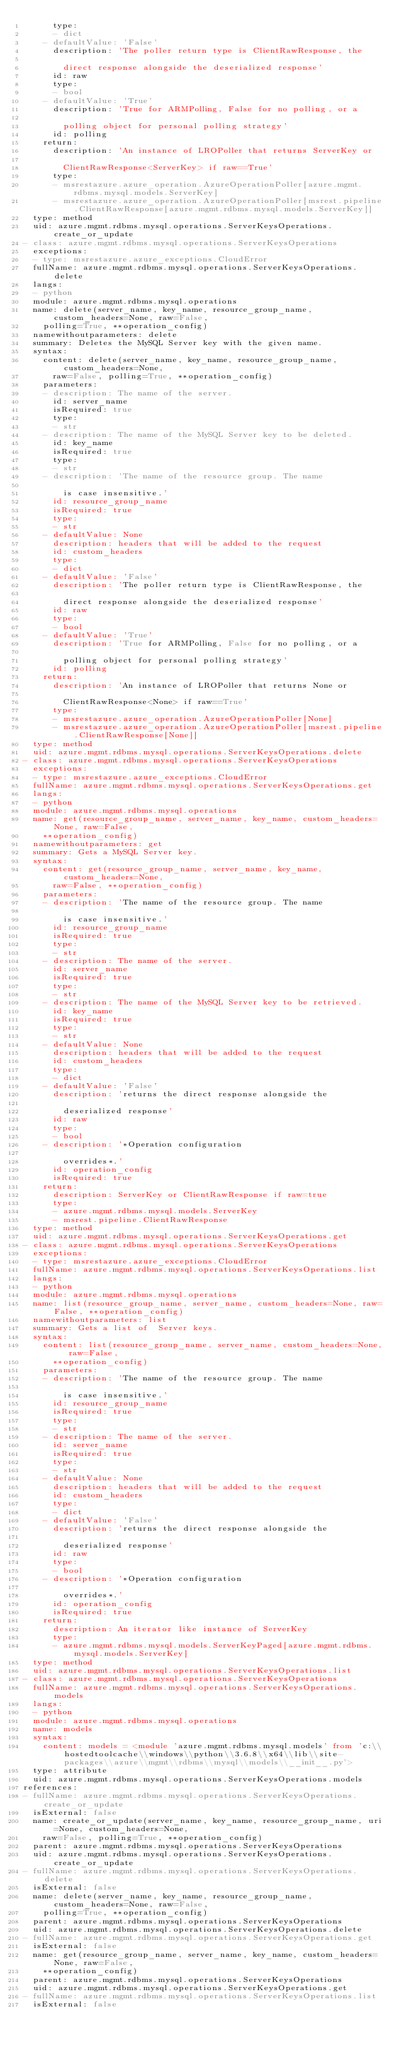<code> <loc_0><loc_0><loc_500><loc_500><_YAML_>      type:
      - dict
    - defaultValue: 'False'
      description: 'The poller return type is ClientRawResponse, the

        direct response alongside the deserialized response'
      id: raw
      type:
      - bool
    - defaultValue: 'True'
      description: 'True for ARMPolling, False for no polling, or a

        polling object for personal polling strategy'
      id: polling
    return:
      description: 'An instance of LROPoller that returns ServerKey or

        ClientRawResponse<ServerKey> if raw==True'
      type:
      - msrestazure.azure_operation.AzureOperationPoller[azure.mgmt.rdbms.mysql.models.ServerKey]
      - msrestazure.azure_operation.AzureOperationPoller[msrest.pipeline.ClientRawResponse[azure.mgmt.rdbms.mysql.models.ServerKey]]
  type: method
  uid: azure.mgmt.rdbms.mysql.operations.ServerKeysOperations.create_or_update
- class: azure.mgmt.rdbms.mysql.operations.ServerKeysOperations
  exceptions:
  - type: msrestazure.azure_exceptions.CloudError
  fullName: azure.mgmt.rdbms.mysql.operations.ServerKeysOperations.delete
  langs:
  - python
  module: azure.mgmt.rdbms.mysql.operations
  name: delete(server_name, key_name, resource_group_name, custom_headers=None, raw=False,
    polling=True, **operation_config)
  namewithoutparameters: delete
  summary: Deletes the MySQL Server key with the given name.
  syntax:
    content: delete(server_name, key_name, resource_group_name, custom_headers=None,
      raw=False, polling=True, **operation_config)
    parameters:
    - description: The name of the server.
      id: server_name
      isRequired: true
      type:
      - str
    - description: The name of the MySQL Server key to be deleted.
      id: key_name
      isRequired: true
      type:
      - str
    - description: 'The name of the resource group. The name

        is case insensitive.'
      id: resource_group_name
      isRequired: true
      type:
      - str
    - defaultValue: None
      description: headers that will be added to the request
      id: custom_headers
      type:
      - dict
    - defaultValue: 'False'
      description: 'The poller return type is ClientRawResponse, the

        direct response alongside the deserialized response'
      id: raw
      type:
      - bool
    - defaultValue: 'True'
      description: 'True for ARMPolling, False for no polling, or a

        polling object for personal polling strategy'
      id: polling
    return:
      description: 'An instance of LROPoller that returns None or

        ClientRawResponse<None> if raw==True'
      type:
      - msrestazure.azure_operation.AzureOperationPoller[None]
      - msrestazure.azure_operation.AzureOperationPoller[msrest.pipeline.ClientRawResponse[None]]
  type: method
  uid: azure.mgmt.rdbms.mysql.operations.ServerKeysOperations.delete
- class: azure.mgmt.rdbms.mysql.operations.ServerKeysOperations
  exceptions:
  - type: msrestazure.azure_exceptions.CloudError
  fullName: azure.mgmt.rdbms.mysql.operations.ServerKeysOperations.get
  langs:
  - python
  module: azure.mgmt.rdbms.mysql.operations
  name: get(resource_group_name, server_name, key_name, custom_headers=None, raw=False,
    **operation_config)
  namewithoutparameters: get
  summary: Gets a MySQL Server key.
  syntax:
    content: get(resource_group_name, server_name, key_name, custom_headers=None,
      raw=False, **operation_config)
    parameters:
    - description: 'The name of the resource group. The name

        is case insensitive.'
      id: resource_group_name
      isRequired: true
      type:
      - str
    - description: The name of the server.
      id: server_name
      isRequired: true
      type:
      - str
    - description: The name of the MySQL Server key to be retrieved.
      id: key_name
      isRequired: true
      type:
      - str
    - defaultValue: None
      description: headers that will be added to the request
      id: custom_headers
      type:
      - dict
    - defaultValue: 'False'
      description: 'returns the direct response alongside the

        deserialized response'
      id: raw
      type:
      - bool
    - description: '*Operation configuration

        overrides*.'
      id: operation_config
      isRequired: true
    return:
      description: ServerKey or ClientRawResponse if raw=true
      type:
      - azure.mgmt.rdbms.mysql.models.ServerKey
      - msrest.pipeline.ClientRawResponse
  type: method
  uid: azure.mgmt.rdbms.mysql.operations.ServerKeysOperations.get
- class: azure.mgmt.rdbms.mysql.operations.ServerKeysOperations
  exceptions:
  - type: msrestazure.azure_exceptions.CloudError
  fullName: azure.mgmt.rdbms.mysql.operations.ServerKeysOperations.list
  langs:
  - python
  module: azure.mgmt.rdbms.mysql.operations
  name: list(resource_group_name, server_name, custom_headers=None, raw=False, **operation_config)
  namewithoutparameters: list
  summary: Gets a list of  Server keys.
  syntax:
    content: list(resource_group_name, server_name, custom_headers=None, raw=False,
      **operation_config)
    parameters:
    - description: 'The name of the resource group. The name

        is case insensitive.'
      id: resource_group_name
      isRequired: true
      type:
      - str
    - description: The name of the server.
      id: server_name
      isRequired: true
      type:
      - str
    - defaultValue: None
      description: headers that will be added to the request
      id: custom_headers
      type:
      - dict
    - defaultValue: 'False'
      description: 'returns the direct response alongside the

        deserialized response'
      id: raw
      type:
      - bool
    - description: '*Operation configuration

        overrides*.'
      id: operation_config
      isRequired: true
    return:
      description: An iterator like instance of ServerKey
      type:
      - azure.mgmt.rdbms.mysql.models.ServerKeyPaged[azure.mgmt.rdbms.mysql.models.ServerKey]
  type: method
  uid: azure.mgmt.rdbms.mysql.operations.ServerKeysOperations.list
- class: azure.mgmt.rdbms.mysql.operations.ServerKeysOperations
  fullName: azure.mgmt.rdbms.mysql.operations.ServerKeysOperations.models
  langs:
  - python
  module: azure.mgmt.rdbms.mysql.operations
  name: models
  syntax:
    content: models = <module 'azure.mgmt.rdbms.mysql.models' from 'c:\\hostedtoolcache\\windows\\python\\3.6.8\\x64\\lib\\site-packages\\azure\\mgmt\\rdbms\\mysql\\models\\__init__.py'>
  type: attribute
  uid: azure.mgmt.rdbms.mysql.operations.ServerKeysOperations.models
references:
- fullName: azure.mgmt.rdbms.mysql.operations.ServerKeysOperations.create_or_update
  isExternal: false
  name: create_or_update(server_name, key_name, resource_group_name, uri=None, custom_headers=None,
    raw=False, polling=True, **operation_config)
  parent: azure.mgmt.rdbms.mysql.operations.ServerKeysOperations
  uid: azure.mgmt.rdbms.mysql.operations.ServerKeysOperations.create_or_update
- fullName: azure.mgmt.rdbms.mysql.operations.ServerKeysOperations.delete
  isExternal: false
  name: delete(server_name, key_name, resource_group_name, custom_headers=None, raw=False,
    polling=True, **operation_config)
  parent: azure.mgmt.rdbms.mysql.operations.ServerKeysOperations
  uid: azure.mgmt.rdbms.mysql.operations.ServerKeysOperations.delete
- fullName: azure.mgmt.rdbms.mysql.operations.ServerKeysOperations.get
  isExternal: false
  name: get(resource_group_name, server_name, key_name, custom_headers=None, raw=False,
    **operation_config)
  parent: azure.mgmt.rdbms.mysql.operations.ServerKeysOperations
  uid: azure.mgmt.rdbms.mysql.operations.ServerKeysOperations.get
- fullName: azure.mgmt.rdbms.mysql.operations.ServerKeysOperations.list
  isExternal: false</code> 